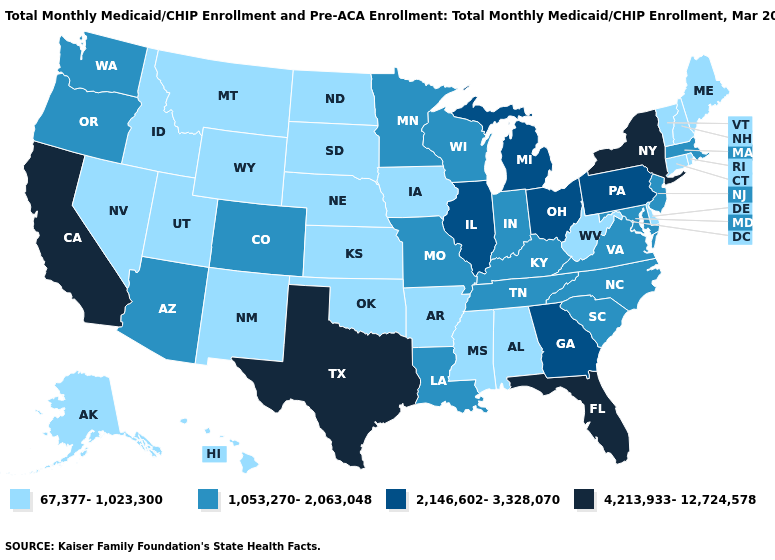Name the states that have a value in the range 2,146,602-3,328,070?
Concise answer only. Georgia, Illinois, Michigan, Ohio, Pennsylvania. How many symbols are there in the legend?
Write a very short answer. 4. How many symbols are there in the legend?
Write a very short answer. 4. Which states have the highest value in the USA?
Concise answer only. California, Florida, New York, Texas. Among the states that border New Mexico , does Texas have the highest value?
Answer briefly. Yes. Which states have the highest value in the USA?
Write a very short answer. California, Florida, New York, Texas. Does Massachusetts have the same value as Pennsylvania?
Keep it brief. No. Does Arizona have the same value as New Jersey?
Quick response, please. Yes. Does Michigan have the highest value in the MidWest?
Concise answer only. Yes. How many symbols are there in the legend?
Write a very short answer. 4. Name the states that have a value in the range 1,053,270-2,063,048?
Be succinct. Arizona, Colorado, Indiana, Kentucky, Louisiana, Maryland, Massachusetts, Minnesota, Missouri, New Jersey, North Carolina, Oregon, South Carolina, Tennessee, Virginia, Washington, Wisconsin. Name the states that have a value in the range 67,377-1,023,300?
Write a very short answer. Alabama, Alaska, Arkansas, Connecticut, Delaware, Hawaii, Idaho, Iowa, Kansas, Maine, Mississippi, Montana, Nebraska, Nevada, New Hampshire, New Mexico, North Dakota, Oklahoma, Rhode Island, South Dakota, Utah, Vermont, West Virginia, Wyoming. What is the value of Wyoming?
Write a very short answer. 67,377-1,023,300. What is the highest value in states that border Georgia?
Keep it brief. 4,213,933-12,724,578. What is the value of Pennsylvania?
Answer briefly. 2,146,602-3,328,070. 